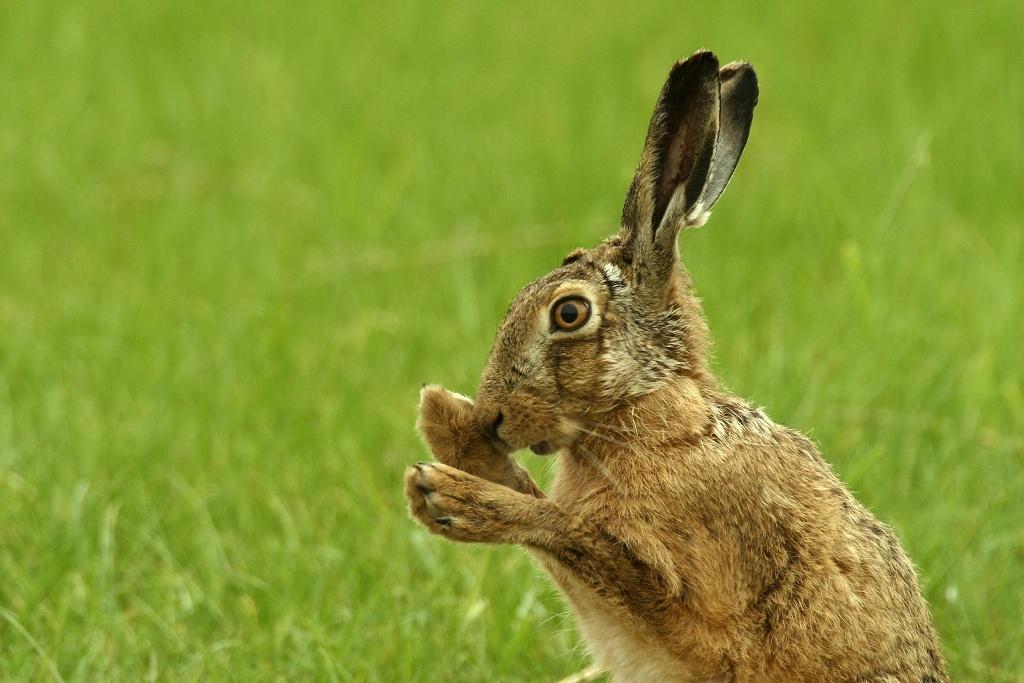Describe this image in one or two sentences. In this image I can see an animal which is brown, black and cream in color. In the background I can see the grass which is green in color. 